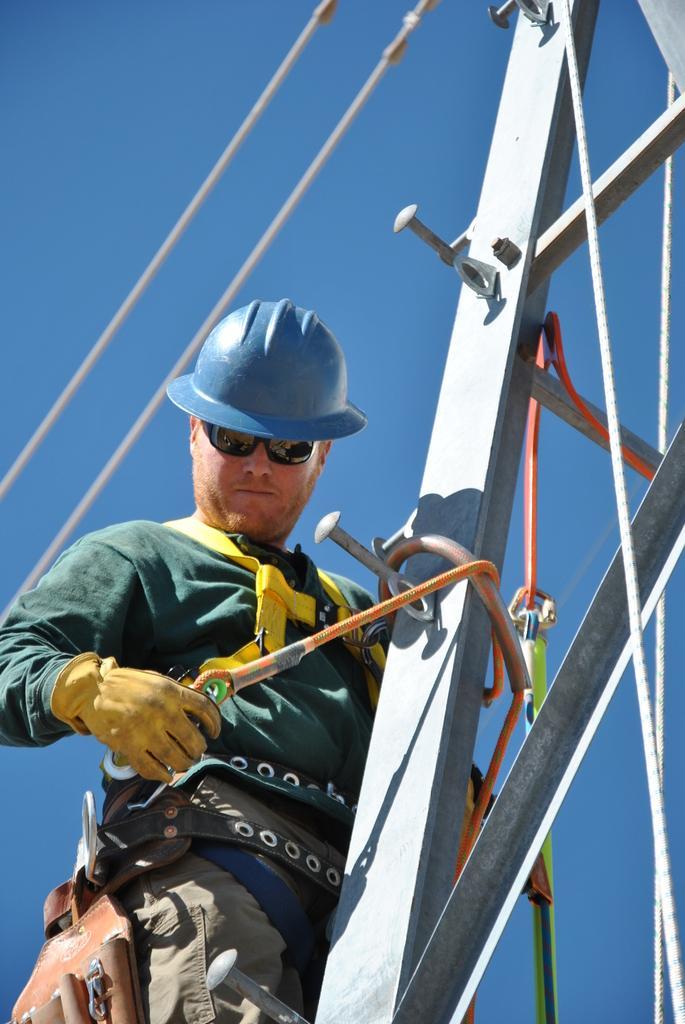Please provide a concise description of this image. Here in this picture we can see a person standing on a tower over there and we can see he is wearing gloves, goggles and helmet on him and he is tying a rope to the tower over there and above him we can see wires present over there. 